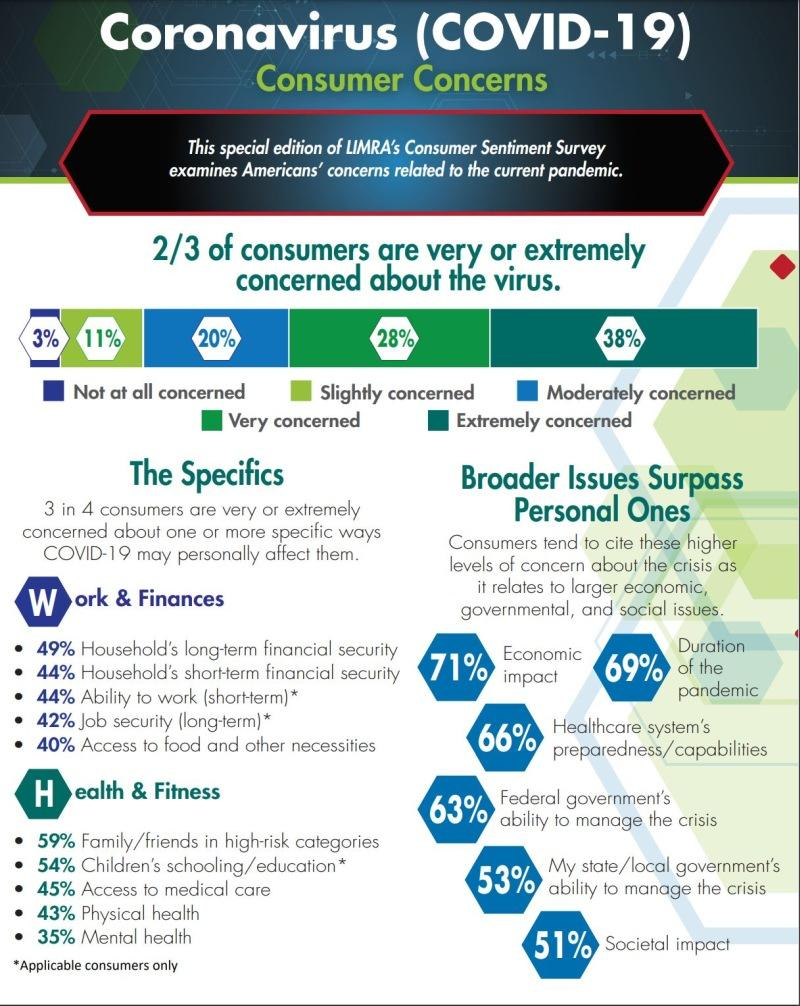Draw attention to some important aspects in this diagram. According to the survey, 28% of consumers are extremely concerned about the virus. The most pressing concern under broader issues is the economic impact. 